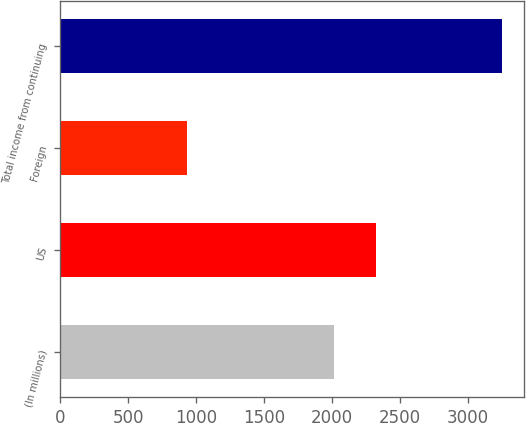<chart> <loc_0><loc_0><loc_500><loc_500><bar_chart><fcel>(In millions)<fcel>US<fcel>Foreign<fcel>Total income from continuing<nl><fcel>2016<fcel>2319<fcel>931<fcel>3250<nl></chart> 